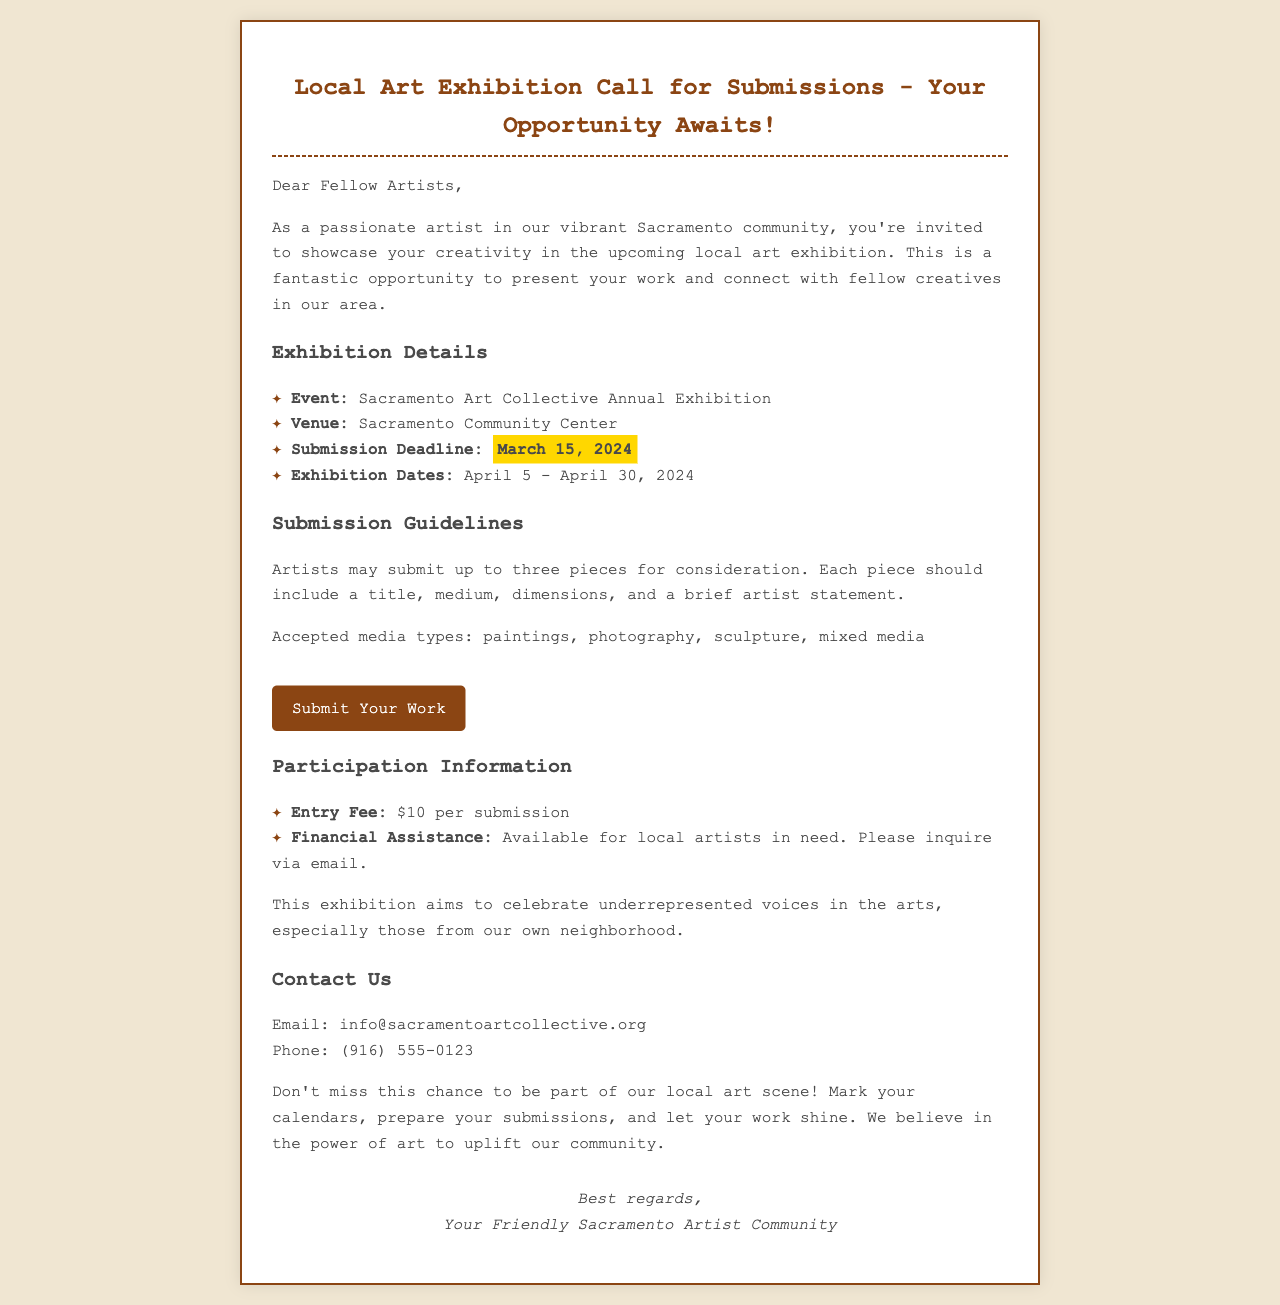what is the event title? The event title is stated in the document under Exhibition Details.
Answer: Sacramento Art Collective Annual Exhibition what is the submission deadline? The submission deadline is highlighted in the document for emphasis.
Answer: March 15, 2024 how many pieces can an artist submit? The document specifies the number of pieces allowed in the Submission Guidelines section.
Answer: Three what is the entry fee? The entry fee is listed under Participation Information.
Answer: $10 per submission what is the aim of the exhibition? The document mentions the aim of the exhibition in a specific paragraph.
Answer: Celebrate underrepresented voices what is the venue for the exhibition? The venue is listed in the Exhibition Details section of the document.
Answer: Sacramento Community Center is financial assistance available? The document clearly states the availability of financial assistance for local artists.
Answer: Yes what are the exhibition dates? The exhibition dates are mentioned in the Exhibition Details section.
Answer: April 5 - April 30, 2024 